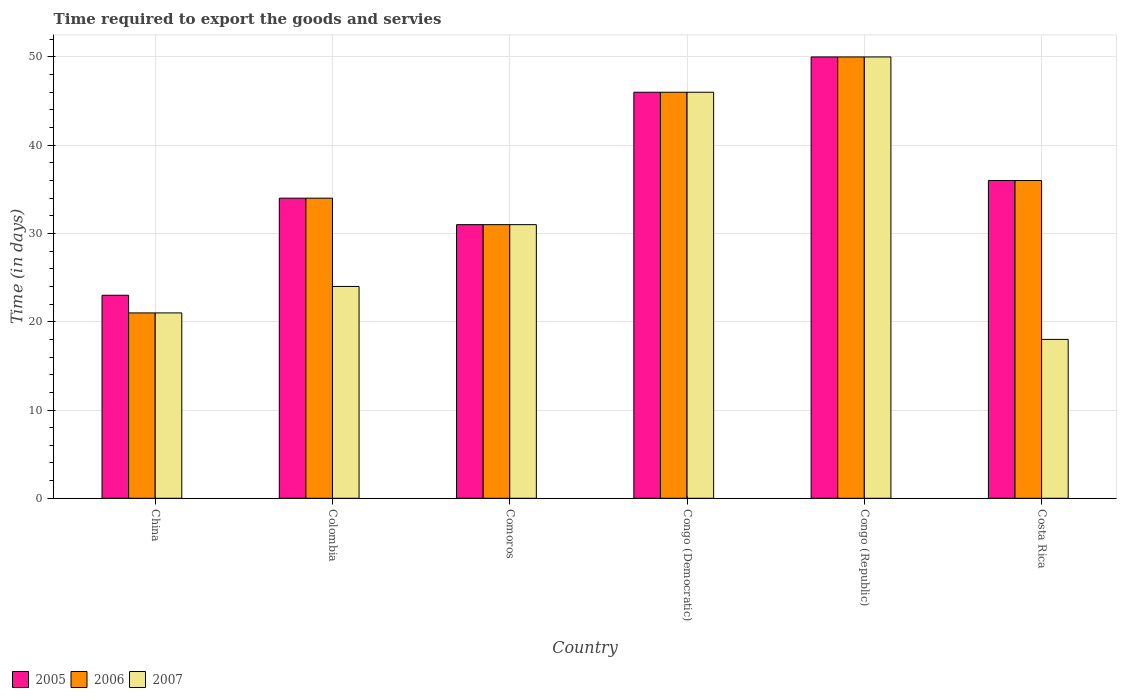Are the number of bars per tick equal to the number of legend labels?
Provide a short and direct response. Yes. Are the number of bars on each tick of the X-axis equal?
Give a very brief answer. Yes. What is the label of the 3rd group of bars from the left?
Provide a succinct answer. Comoros. In how many cases, is the number of bars for a given country not equal to the number of legend labels?
Your answer should be very brief. 0. Across all countries, what is the maximum number of days required to export the goods and services in 2005?
Your answer should be compact. 50. Across all countries, what is the minimum number of days required to export the goods and services in 2005?
Provide a short and direct response. 23. In which country was the number of days required to export the goods and services in 2007 maximum?
Keep it short and to the point. Congo (Republic). What is the total number of days required to export the goods and services in 2006 in the graph?
Offer a terse response. 218. What is the difference between the number of days required to export the goods and services in 2007 in Congo (Republic) and that in Costa Rica?
Offer a very short reply. 32. What is the average number of days required to export the goods and services in 2005 per country?
Ensure brevity in your answer.  36.67. What is the difference between the number of days required to export the goods and services of/in 2005 and number of days required to export the goods and services of/in 2007 in Congo (Democratic)?
Offer a very short reply. 0. What is the ratio of the number of days required to export the goods and services in 2007 in Congo (Republic) to that in Costa Rica?
Offer a terse response. 2.78. What is the difference between the highest and the lowest number of days required to export the goods and services in 2006?
Give a very brief answer. 29. Is it the case that in every country, the sum of the number of days required to export the goods and services in 2006 and number of days required to export the goods and services in 2007 is greater than the number of days required to export the goods and services in 2005?
Your answer should be compact. Yes. How many bars are there?
Keep it short and to the point. 18. Are all the bars in the graph horizontal?
Offer a very short reply. No. How many countries are there in the graph?
Keep it short and to the point. 6. Are the values on the major ticks of Y-axis written in scientific E-notation?
Offer a terse response. No. Does the graph contain any zero values?
Your answer should be compact. No. Does the graph contain grids?
Ensure brevity in your answer.  Yes. How are the legend labels stacked?
Provide a short and direct response. Horizontal. What is the title of the graph?
Ensure brevity in your answer.  Time required to export the goods and servies. What is the label or title of the Y-axis?
Your answer should be compact. Time (in days). What is the Time (in days) in 2006 in China?
Give a very brief answer. 21. What is the Time (in days) of 2005 in Colombia?
Make the answer very short. 34. What is the Time (in days) of 2006 in Colombia?
Your answer should be compact. 34. What is the Time (in days) of 2007 in Colombia?
Give a very brief answer. 24. What is the Time (in days) of 2005 in Comoros?
Provide a short and direct response. 31. What is the Time (in days) of 2006 in Comoros?
Ensure brevity in your answer.  31. What is the Time (in days) of 2007 in Comoros?
Give a very brief answer. 31. What is the Time (in days) of 2005 in Congo (Democratic)?
Your answer should be compact. 46. What is the Time (in days) in 2006 in Congo (Democratic)?
Give a very brief answer. 46. Across all countries, what is the maximum Time (in days) in 2005?
Your answer should be very brief. 50. Across all countries, what is the maximum Time (in days) of 2007?
Offer a terse response. 50. Across all countries, what is the minimum Time (in days) in 2007?
Keep it short and to the point. 18. What is the total Time (in days) in 2005 in the graph?
Make the answer very short. 220. What is the total Time (in days) in 2006 in the graph?
Keep it short and to the point. 218. What is the total Time (in days) of 2007 in the graph?
Make the answer very short. 190. What is the difference between the Time (in days) in 2005 in China and that in Colombia?
Your answer should be compact. -11. What is the difference between the Time (in days) of 2006 in China and that in Colombia?
Your response must be concise. -13. What is the difference between the Time (in days) of 2006 in China and that in Comoros?
Your answer should be very brief. -10. What is the difference between the Time (in days) of 2007 in China and that in Comoros?
Offer a very short reply. -10. What is the difference between the Time (in days) of 2005 in China and that in Congo (Republic)?
Your response must be concise. -27. What is the difference between the Time (in days) of 2006 in China and that in Congo (Republic)?
Offer a very short reply. -29. What is the difference between the Time (in days) of 2005 in China and that in Costa Rica?
Offer a terse response. -13. What is the difference between the Time (in days) in 2006 in China and that in Costa Rica?
Provide a succinct answer. -15. What is the difference between the Time (in days) of 2006 in Colombia and that in Comoros?
Make the answer very short. 3. What is the difference between the Time (in days) in 2006 in Colombia and that in Congo (Democratic)?
Provide a short and direct response. -12. What is the difference between the Time (in days) in 2007 in Colombia and that in Congo (Democratic)?
Your answer should be compact. -22. What is the difference between the Time (in days) of 2006 in Colombia and that in Congo (Republic)?
Make the answer very short. -16. What is the difference between the Time (in days) in 2007 in Colombia and that in Congo (Republic)?
Provide a short and direct response. -26. What is the difference between the Time (in days) of 2006 in Colombia and that in Costa Rica?
Offer a terse response. -2. What is the difference between the Time (in days) in 2005 in Comoros and that in Congo (Republic)?
Offer a terse response. -19. What is the difference between the Time (in days) in 2006 in Comoros and that in Congo (Republic)?
Your response must be concise. -19. What is the difference between the Time (in days) in 2007 in Comoros and that in Congo (Republic)?
Your answer should be compact. -19. What is the difference between the Time (in days) in 2005 in Comoros and that in Costa Rica?
Offer a very short reply. -5. What is the difference between the Time (in days) in 2007 in Comoros and that in Costa Rica?
Offer a very short reply. 13. What is the difference between the Time (in days) in 2005 in Congo (Democratic) and that in Congo (Republic)?
Your answer should be compact. -4. What is the difference between the Time (in days) in 2007 in Congo (Democratic) and that in Congo (Republic)?
Your answer should be very brief. -4. What is the difference between the Time (in days) of 2005 in Congo (Democratic) and that in Costa Rica?
Keep it short and to the point. 10. What is the difference between the Time (in days) of 2006 in Congo (Democratic) and that in Costa Rica?
Your response must be concise. 10. What is the difference between the Time (in days) of 2007 in Congo (Democratic) and that in Costa Rica?
Ensure brevity in your answer.  28. What is the difference between the Time (in days) in 2005 in Congo (Republic) and that in Costa Rica?
Provide a short and direct response. 14. What is the difference between the Time (in days) in 2006 in Congo (Republic) and that in Costa Rica?
Keep it short and to the point. 14. What is the difference between the Time (in days) in 2005 in China and the Time (in days) in 2006 in Comoros?
Your answer should be very brief. -8. What is the difference between the Time (in days) in 2005 in China and the Time (in days) in 2006 in Congo (Democratic)?
Provide a succinct answer. -23. What is the difference between the Time (in days) in 2005 in China and the Time (in days) in 2007 in Congo (Democratic)?
Make the answer very short. -23. What is the difference between the Time (in days) of 2006 in China and the Time (in days) of 2007 in Congo (Democratic)?
Offer a very short reply. -25. What is the difference between the Time (in days) of 2005 in China and the Time (in days) of 2006 in Congo (Republic)?
Ensure brevity in your answer.  -27. What is the difference between the Time (in days) of 2005 in China and the Time (in days) of 2007 in Congo (Republic)?
Offer a very short reply. -27. What is the difference between the Time (in days) in 2005 in China and the Time (in days) in 2007 in Costa Rica?
Provide a short and direct response. 5. What is the difference between the Time (in days) of 2006 in China and the Time (in days) of 2007 in Costa Rica?
Keep it short and to the point. 3. What is the difference between the Time (in days) of 2005 in Colombia and the Time (in days) of 2006 in Comoros?
Provide a succinct answer. 3. What is the difference between the Time (in days) of 2006 in Colombia and the Time (in days) of 2007 in Comoros?
Offer a very short reply. 3. What is the difference between the Time (in days) in 2005 in Colombia and the Time (in days) in 2006 in Congo (Democratic)?
Your answer should be compact. -12. What is the difference between the Time (in days) of 2006 in Colombia and the Time (in days) of 2007 in Congo (Democratic)?
Give a very brief answer. -12. What is the difference between the Time (in days) of 2005 in Colombia and the Time (in days) of 2007 in Congo (Republic)?
Offer a very short reply. -16. What is the difference between the Time (in days) of 2005 in Colombia and the Time (in days) of 2006 in Costa Rica?
Offer a very short reply. -2. What is the difference between the Time (in days) of 2006 in Colombia and the Time (in days) of 2007 in Costa Rica?
Provide a succinct answer. 16. What is the difference between the Time (in days) of 2005 in Comoros and the Time (in days) of 2007 in Congo (Democratic)?
Provide a succinct answer. -15. What is the difference between the Time (in days) in 2005 in Comoros and the Time (in days) in 2006 in Congo (Republic)?
Make the answer very short. -19. What is the difference between the Time (in days) in 2006 in Comoros and the Time (in days) in 2007 in Congo (Republic)?
Offer a terse response. -19. What is the difference between the Time (in days) of 2005 in Comoros and the Time (in days) of 2007 in Costa Rica?
Your answer should be very brief. 13. What is the difference between the Time (in days) in 2005 in Congo (Democratic) and the Time (in days) in 2006 in Congo (Republic)?
Your answer should be compact. -4. What is the difference between the Time (in days) of 2006 in Congo (Democratic) and the Time (in days) of 2007 in Congo (Republic)?
Provide a short and direct response. -4. What is the difference between the Time (in days) in 2005 in Congo (Democratic) and the Time (in days) in 2006 in Costa Rica?
Keep it short and to the point. 10. What is the difference between the Time (in days) of 2005 in Congo (Democratic) and the Time (in days) of 2007 in Costa Rica?
Your response must be concise. 28. What is the difference between the Time (in days) of 2005 in Congo (Republic) and the Time (in days) of 2007 in Costa Rica?
Offer a terse response. 32. What is the average Time (in days) in 2005 per country?
Provide a short and direct response. 36.67. What is the average Time (in days) in 2006 per country?
Offer a terse response. 36.33. What is the average Time (in days) of 2007 per country?
Offer a terse response. 31.67. What is the difference between the Time (in days) in 2006 and Time (in days) in 2007 in China?
Provide a short and direct response. 0. What is the difference between the Time (in days) in 2005 and Time (in days) in 2007 in Colombia?
Ensure brevity in your answer.  10. What is the difference between the Time (in days) of 2005 and Time (in days) of 2007 in Comoros?
Provide a short and direct response. 0. What is the difference between the Time (in days) of 2006 and Time (in days) of 2007 in Comoros?
Provide a short and direct response. 0. What is the difference between the Time (in days) of 2005 and Time (in days) of 2006 in Congo (Republic)?
Make the answer very short. 0. What is the difference between the Time (in days) of 2005 and Time (in days) of 2007 in Congo (Republic)?
Your answer should be compact. 0. What is the difference between the Time (in days) of 2006 and Time (in days) of 2007 in Congo (Republic)?
Make the answer very short. 0. What is the difference between the Time (in days) in 2006 and Time (in days) in 2007 in Costa Rica?
Give a very brief answer. 18. What is the ratio of the Time (in days) of 2005 in China to that in Colombia?
Make the answer very short. 0.68. What is the ratio of the Time (in days) of 2006 in China to that in Colombia?
Your answer should be very brief. 0.62. What is the ratio of the Time (in days) of 2007 in China to that in Colombia?
Your response must be concise. 0.88. What is the ratio of the Time (in days) in 2005 in China to that in Comoros?
Keep it short and to the point. 0.74. What is the ratio of the Time (in days) in 2006 in China to that in Comoros?
Provide a short and direct response. 0.68. What is the ratio of the Time (in days) of 2007 in China to that in Comoros?
Your answer should be compact. 0.68. What is the ratio of the Time (in days) of 2006 in China to that in Congo (Democratic)?
Provide a succinct answer. 0.46. What is the ratio of the Time (in days) of 2007 in China to that in Congo (Democratic)?
Keep it short and to the point. 0.46. What is the ratio of the Time (in days) in 2005 in China to that in Congo (Republic)?
Your answer should be compact. 0.46. What is the ratio of the Time (in days) in 2006 in China to that in Congo (Republic)?
Provide a short and direct response. 0.42. What is the ratio of the Time (in days) in 2007 in China to that in Congo (Republic)?
Give a very brief answer. 0.42. What is the ratio of the Time (in days) in 2005 in China to that in Costa Rica?
Keep it short and to the point. 0.64. What is the ratio of the Time (in days) in 2006 in China to that in Costa Rica?
Make the answer very short. 0.58. What is the ratio of the Time (in days) in 2007 in China to that in Costa Rica?
Provide a succinct answer. 1.17. What is the ratio of the Time (in days) of 2005 in Colombia to that in Comoros?
Your response must be concise. 1.1. What is the ratio of the Time (in days) in 2006 in Colombia to that in Comoros?
Offer a very short reply. 1.1. What is the ratio of the Time (in days) in 2007 in Colombia to that in Comoros?
Offer a very short reply. 0.77. What is the ratio of the Time (in days) in 2005 in Colombia to that in Congo (Democratic)?
Provide a short and direct response. 0.74. What is the ratio of the Time (in days) in 2006 in Colombia to that in Congo (Democratic)?
Provide a short and direct response. 0.74. What is the ratio of the Time (in days) in 2007 in Colombia to that in Congo (Democratic)?
Offer a very short reply. 0.52. What is the ratio of the Time (in days) of 2005 in Colombia to that in Congo (Republic)?
Provide a succinct answer. 0.68. What is the ratio of the Time (in days) of 2006 in Colombia to that in Congo (Republic)?
Give a very brief answer. 0.68. What is the ratio of the Time (in days) in 2007 in Colombia to that in Congo (Republic)?
Your answer should be compact. 0.48. What is the ratio of the Time (in days) in 2005 in Colombia to that in Costa Rica?
Provide a short and direct response. 0.94. What is the ratio of the Time (in days) in 2006 in Colombia to that in Costa Rica?
Provide a succinct answer. 0.94. What is the ratio of the Time (in days) in 2007 in Colombia to that in Costa Rica?
Make the answer very short. 1.33. What is the ratio of the Time (in days) in 2005 in Comoros to that in Congo (Democratic)?
Your answer should be very brief. 0.67. What is the ratio of the Time (in days) in 2006 in Comoros to that in Congo (Democratic)?
Ensure brevity in your answer.  0.67. What is the ratio of the Time (in days) of 2007 in Comoros to that in Congo (Democratic)?
Provide a succinct answer. 0.67. What is the ratio of the Time (in days) of 2005 in Comoros to that in Congo (Republic)?
Give a very brief answer. 0.62. What is the ratio of the Time (in days) of 2006 in Comoros to that in Congo (Republic)?
Your response must be concise. 0.62. What is the ratio of the Time (in days) in 2007 in Comoros to that in Congo (Republic)?
Offer a terse response. 0.62. What is the ratio of the Time (in days) in 2005 in Comoros to that in Costa Rica?
Ensure brevity in your answer.  0.86. What is the ratio of the Time (in days) in 2006 in Comoros to that in Costa Rica?
Your response must be concise. 0.86. What is the ratio of the Time (in days) of 2007 in Comoros to that in Costa Rica?
Ensure brevity in your answer.  1.72. What is the ratio of the Time (in days) in 2005 in Congo (Democratic) to that in Congo (Republic)?
Your response must be concise. 0.92. What is the ratio of the Time (in days) of 2006 in Congo (Democratic) to that in Congo (Republic)?
Keep it short and to the point. 0.92. What is the ratio of the Time (in days) of 2005 in Congo (Democratic) to that in Costa Rica?
Your answer should be compact. 1.28. What is the ratio of the Time (in days) of 2006 in Congo (Democratic) to that in Costa Rica?
Your answer should be compact. 1.28. What is the ratio of the Time (in days) in 2007 in Congo (Democratic) to that in Costa Rica?
Your answer should be compact. 2.56. What is the ratio of the Time (in days) in 2005 in Congo (Republic) to that in Costa Rica?
Your response must be concise. 1.39. What is the ratio of the Time (in days) of 2006 in Congo (Republic) to that in Costa Rica?
Make the answer very short. 1.39. What is the ratio of the Time (in days) of 2007 in Congo (Republic) to that in Costa Rica?
Give a very brief answer. 2.78. What is the difference between the highest and the second highest Time (in days) in 2006?
Your answer should be compact. 4. What is the difference between the highest and the second highest Time (in days) of 2007?
Your answer should be compact. 4. 